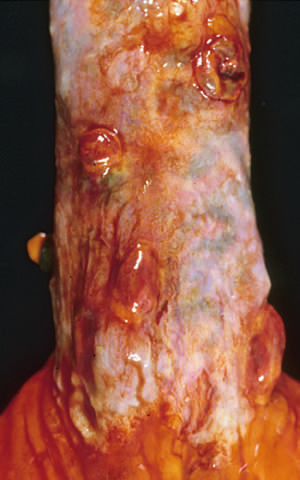re collapsed varices present in this postmortem specimen corresponding to the angiogram in the figure?
Answer the question using a single word or phrase. Yes 